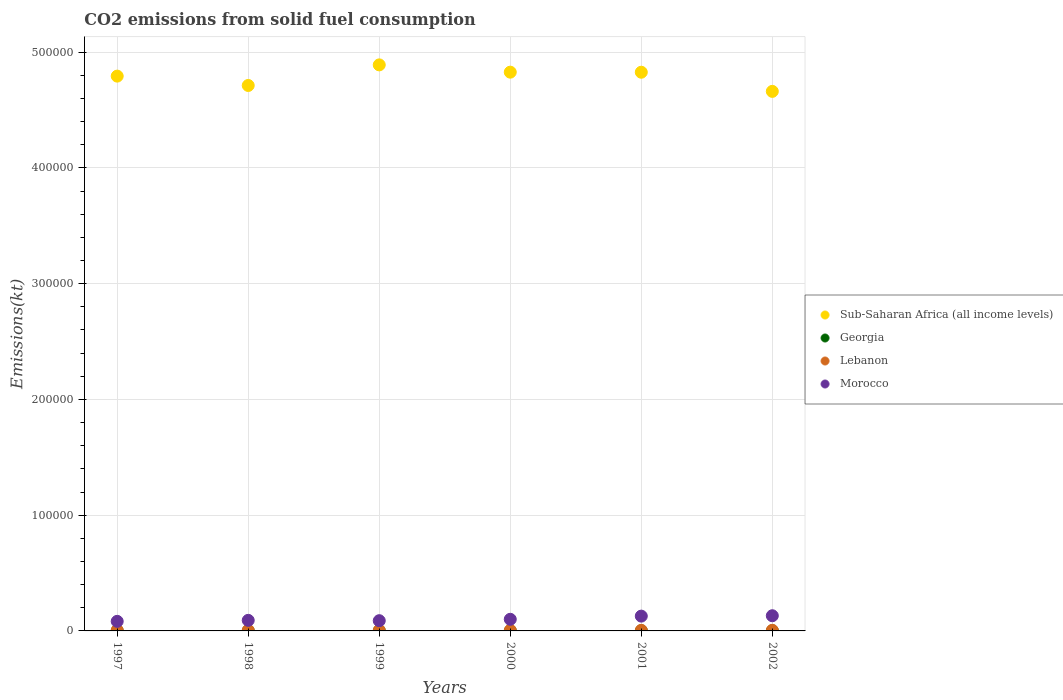How many different coloured dotlines are there?
Ensure brevity in your answer.  4. What is the amount of CO2 emitted in Lebanon in 2001?
Offer a very short reply. 531.72. Across all years, what is the maximum amount of CO2 emitted in Sub-Saharan Africa (all income levels)?
Provide a succinct answer. 4.89e+05. Across all years, what is the minimum amount of CO2 emitted in Lebanon?
Provide a succinct answer. 531.72. In which year was the amount of CO2 emitted in Lebanon maximum?
Ensure brevity in your answer.  1997. In which year was the amount of CO2 emitted in Morocco minimum?
Offer a very short reply. 1997. What is the total amount of CO2 emitted in Sub-Saharan Africa (all income levels) in the graph?
Keep it short and to the point. 2.87e+06. What is the difference between the amount of CO2 emitted in Morocco in 1999 and that in 2001?
Offer a terse response. -3942.03. What is the difference between the amount of CO2 emitted in Sub-Saharan Africa (all income levels) in 1998 and the amount of CO2 emitted in Morocco in 2001?
Your response must be concise. 4.58e+05. What is the average amount of CO2 emitted in Sub-Saharan Africa (all income levels) per year?
Provide a short and direct response. 4.78e+05. In the year 2002, what is the difference between the amount of CO2 emitted in Georgia and amount of CO2 emitted in Sub-Saharan Africa (all income levels)?
Keep it short and to the point. -4.66e+05. What is the ratio of the amount of CO2 emitted in Lebanon in 1999 to that in 2000?
Your answer should be compact. 1. What is the difference between the highest and the second highest amount of CO2 emitted in Morocco?
Give a very brief answer. 333.7. What is the difference between the highest and the lowest amount of CO2 emitted in Sub-Saharan Africa (all income levels)?
Offer a very short reply. 2.29e+04. Is the sum of the amount of CO2 emitted in Morocco in 2001 and 2002 greater than the maximum amount of CO2 emitted in Lebanon across all years?
Give a very brief answer. Yes. Is it the case that in every year, the sum of the amount of CO2 emitted in Morocco and amount of CO2 emitted in Sub-Saharan Africa (all income levels)  is greater than the sum of amount of CO2 emitted in Georgia and amount of CO2 emitted in Lebanon?
Your answer should be compact. No. Is it the case that in every year, the sum of the amount of CO2 emitted in Georgia and amount of CO2 emitted in Sub-Saharan Africa (all income levels)  is greater than the amount of CO2 emitted in Morocco?
Keep it short and to the point. Yes. Does the amount of CO2 emitted in Lebanon monotonically increase over the years?
Keep it short and to the point. No. Is the amount of CO2 emitted in Sub-Saharan Africa (all income levels) strictly greater than the amount of CO2 emitted in Morocco over the years?
Provide a succinct answer. Yes. Is the amount of CO2 emitted in Georgia strictly less than the amount of CO2 emitted in Sub-Saharan Africa (all income levels) over the years?
Provide a succinct answer. Yes. How many years are there in the graph?
Your answer should be very brief. 6. What is the difference between two consecutive major ticks on the Y-axis?
Provide a short and direct response. 1.00e+05. Does the graph contain grids?
Offer a terse response. Yes. Where does the legend appear in the graph?
Your answer should be very brief. Center right. How many legend labels are there?
Your answer should be compact. 4. What is the title of the graph?
Your response must be concise. CO2 emissions from solid fuel consumption. Does "St. Kitts and Nevis" appear as one of the legend labels in the graph?
Your answer should be very brief. No. What is the label or title of the Y-axis?
Your response must be concise. Emissions(kt). What is the Emissions(kt) of Sub-Saharan Africa (all income levels) in 1997?
Provide a succinct answer. 4.79e+05. What is the Emissions(kt) of Georgia in 1997?
Ensure brevity in your answer.  29.34. What is the Emissions(kt) in Lebanon in 1997?
Your response must be concise. 608.72. What is the Emissions(kt) of Morocco in 1997?
Offer a terse response. 8272.75. What is the Emissions(kt) in Sub-Saharan Africa (all income levels) in 1998?
Your response must be concise. 4.71e+05. What is the Emissions(kt) of Georgia in 1998?
Make the answer very short. 77.01. What is the Emissions(kt) in Lebanon in 1998?
Offer a terse response. 531.72. What is the Emissions(kt) in Morocco in 1998?
Offer a terse response. 9134.5. What is the Emissions(kt) of Sub-Saharan Africa (all income levels) in 1999?
Make the answer very short. 4.89e+05. What is the Emissions(kt) in Georgia in 1999?
Ensure brevity in your answer.  62.34. What is the Emissions(kt) in Lebanon in 1999?
Offer a very short reply. 535.38. What is the Emissions(kt) of Morocco in 1999?
Provide a succinct answer. 8841.14. What is the Emissions(kt) in Sub-Saharan Africa (all income levels) in 2000?
Keep it short and to the point. 4.83e+05. What is the Emissions(kt) in Georgia in 2000?
Provide a succinct answer. 58.67. What is the Emissions(kt) of Lebanon in 2000?
Your response must be concise. 535.38. What is the Emissions(kt) of Morocco in 2000?
Offer a very short reply. 1.00e+04. What is the Emissions(kt) in Sub-Saharan Africa (all income levels) in 2001?
Make the answer very short. 4.83e+05. What is the Emissions(kt) in Georgia in 2001?
Keep it short and to the point. 55.01. What is the Emissions(kt) of Lebanon in 2001?
Provide a succinct answer. 531.72. What is the Emissions(kt) of Morocco in 2001?
Offer a terse response. 1.28e+04. What is the Emissions(kt) of Sub-Saharan Africa (all income levels) in 2002?
Your answer should be compact. 4.66e+05. What is the Emissions(kt) in Georgia in 2002?
Make the answer very short. 55.01. What is the Emissions(kt) of Lebanon in 2002?
Ensure brevity in your answer.  531.72. What is the Emissions(kt) in Morocco in 2002?
Offer a very short reply. 1.31e+04. Across all years, what is the maximum Emissions(kt) in Sub-Saharan Africa (all income levels)?
Ensure brevity in your answer.  4.89e+05. Across all years, what is the maximum Emissions(kt) in Georgia?
Keep it short and to the point. 77.01. Across all years, what is the maximum Emissions(kt) of Lebanon?
Your answer should be very brief. 608.72. Across all years, what is the maximum Emissions(kt) in Morocco?
Ensure brevity in your answer.  1.31e+04. Across all years, what is the minimum Emissions(kt) in Sub-Saharan Africa (all income levels)?
Your answer should be very brief. 4.66e+05. Across all years, what is the minimum Emissions(kt) in Georgia?
Keep it short and to the point. 29.34. Across all years, what is the minimum Emissions(kt) in Lebanon?
Provide a succinct answer. 531.72. Across all years, what is the minimum Emissions(kt) in Morocco?
Your answer should be compact. 8272.75. What is the total Emissions(kt) of Sub-Saharan Africa (all income levels) in the graph?
Provide a short and direct response. 2.87e+06. What is the total Emissions(kt) of Georgia in the graph?
Keep it short and to the point. 337.36. What is the total Emissions(kt) in Lebanon in the graph?
Your answer should be very brief. 3274.63. What is the total Emissions(kt) in Morocco in the graph?
Ensure brevity in your answer.  6.22e+04. What is the difference between the Emissions(kt) in Sub-Saharan Africa (all income levels) in 1997 and that in 1998?
Your answer should be very brief. 8083.93. What is the difference between the Emissions(kt) in Georgia in 1997 and that in 1998?
Give a very brief answer. -47.67. What is the difference between the Emissions(kt) of Lebanon in 1997 and that in 1998?
Keep it short and to the point. 77.01. What is the difference between the Emissions(kt) in Morocco in 1997 and that in 1998?
Keep it short and to the point. -861.75. What is the difference between the Emissions(kt) of Sub-Saharan Africa (all income levels) in 1997 and that in 1999?
Provide a short and direct response. -9710.18. What is the difference between the Emissions(kt) of Georgia in 1997 and that in 1999?
Offer a terse response. -33. What is the difference between the Emissions(kt) of Lebanon in 1997 and that in 1999?
Offer a terse response. 73.34. What is the difference between the Emissions(kt) of Morocco in 1997 and that in 1999?
Give a very brief answer. -568.38. What is the difference between the Emissions(kt) in Sub-Saharan Africa (all income levels) in 1997 and that in 2000?
Provide a succinct answer. -3411.74. What is the difference between the Emissions(kt) in Georgia in 1997 and that in 2000?
Give a very brief answer. -29.34. What is the difference between the Emissions(kt) in Lebanon in 1997 and that in 2000?
Provide a short and direct response. 73.34. What is the difference between the Emissions(kt) in Morocco in 1997 and that in 2000?
Your response must be concise. -1763.83. What is the difference between the Emissions(kt) of Sub-Saharan Africa (all income levels) in 1997 and that in 2001?
Offer a very short reply. -3355.14. What is the difference between the Emissions(kt) in Georgia in 1997 and that in 2001?
Make the answer very short. -25.67. What is the difference between the Emissions(kt) of Lebanon in 1997 and that in 2001?
Offer a terse response. 77.01. What is the difference between the Emissions(kt) in Morocco in 1997 and that in 2001?
Provide a succinct answer. -4510.41. What is the difference between the Emissions(kt) of Sub-Saharan Africa (all income levels) in 1997 and that in 2002?
Your response must be concise. 1.32e+04. What is the difference between the Emissions(kt) in Georgia in 1997 and that in 2002?
Your answer should be compact. -25.67. What is the difference between the Emissions(kt) of Lebanon in 1997 and that in 2002?
Provide a short and direct response. 77.01. What is the difference between the Emissions(kt) in Morocco in 1997 and that in 2002?
Your answer should be compact. -4844.11. What is the difference between the Emissions(kt) of Sub-Saharan Africa (all income levels) in 1998 and that in 1999?
Your response must be concise. -1.78e+04. What is the difference between the Emissions(kt) in Georgia in 1998 and that in 1999?
Make the answer very short. 14.67. What is the difference between the Emissions(kt) in Lebanon in 1998 and that in 1999?
Your answer should be very brief. -3.67. What is the difference between the Emissions(kt) in Morocco in 1998 and that in 1999?
Make the answer very short. 293.36. What is the difference between the Emissions(kt) in Sub-Saharan Africa (all income levels) in 1998 and that in 2000?
Ensure brevity in your answer.  -1.15e+04. What is the difference between the Emissions(kt) of Georgia in 1998 and that in 2000?
Offer a terse response. 18.34. What is the difference between the Emissions(kt) in Lebanon in 1998 and that in 2000?
Keep it short and to the point. -3.67. What is the difference between the Emissions(kt) in Morocco in 1998 and that in 2000?
Keep it short and to the point. -902.08. What is the difference between the Emissions(kt) in Sub-Saharan Africa (all income levels) in 1998 and that in 2001?
Make the answer very short. -1.14e+04. What is the difference between the Emissions(kt) of Georgia in 1998 and that in 2001?
Provide a short and direct response. 22. What is the difference between the Emissions(kt) in Lebanon in 1998 and that in 2001?
Your answer should be very brief. 0. What is the difference between the Emissions(kt) in Morocco in 1998 and that in 2001?
Your answer should be compact. -3648.66. What is the difference between the Emissions(kt) in Sub-Saharan Africa (all income levels) in 1998 and that in 2002?
Your answer should be very brief. 5099.47. What is the difference between the Emissions(kt) in Georgia in 1998 and that in 2002?
Provide a short and direct response. 22. What is the difference between the Emissions(kt) in Morocco in 1998 and that in 2002?
Make the answer very short. -3982.36. What is the difference between the Emissions(kt) of Sub-Saharan Africa (all income levels) in 1999 and that in 2000?
Make the answer very short. 6298.44. What is the difference between the Emissions(kt) in Georgia in 1999 and that in 2000?
Offer a terse response. 3.67. What is the difference between the Emissions(kt) in Lebanon in 1999 and that in 2000?
Keep it short and to the point. 0. What is the difference between the Emissions(kt) of Morocco in 1999 and that in 2000?
Offer a very short reply. -1195.44. What is the difference between the Emissions(kt) of Sub-Saharan Africa (all income levels) in 1999 and that in 2001?
Provide a short and direct response. 6355.04. What is the difference between the Emissions(kt) in Georgia in 1999 and that in 2001?
Your response must be concise. 7.33. What is the difference between the Emissions(kt) in Lebanon in 1999 and that in 2001?
Your response must be concise. 3.67. What is the difference between the Emissions(kt) of Morocco in 1999 and that in 2001?
Ensure brevity in your answer.  -3942.03. What is the difference between the Emissions(kt) in Sub-Saharan Africa (all income levels) in 1999 and that in 2002?
Your answer should be compact. 2.29e+04. What is the difference between the Emissions(kt) in Georgia in 1999 and that in 2002?
Keep it short and to the point. 7.33. What is the difference between the Emissions(kt) of Lebanon in 1999 and that in 2002?
Offer a terse response. 3.67. What is the difference between the Emissions(kt) in Morocco in 1999 and that in 2002?
Ensure brevity in your answer.  -4275.72. What is the difference between the Emissions(kt) in Sub-Saharan Africa (all income levels) in 2000 and that in 2001?
Make the answer very short. 56.6. What is the difference between the Emissions(kt) of Georgia in 2000 and that in 2001?
Ensure brevity in your answer.  3.67. What is the difference between the Emissions(kt) in Lebanon in 2000 and that in 2001?
Provide a short and direct response. 3.67. What is the difference between the Emissions(kt) in Morocco in 2000 and that in 2001?
Your answer should be very brief. -2746.58. What is the difference between the Emissions(kt) in Sub-Saharan Africa (all income levels) in 2000 and that in 2002?
Your response must be concise. 1.66e+04. What is the difference between the Emissions(kt) of Georgia in 2000 and that in 2002?
Give a very brief answer. 3.67. What is the difference between the Emissions(kt) in Lebanon in 2000 and that in 2002?
Ensure brevity in your answer.  3.67. What is the difference between the Emissions(kt) of Morocco in 2000 and that in 2002?
Give a very brief answer. -3080.28. What is the difference between the Emissions(kt) in Sub-Saharan Africa (all income levels) in 2001 and that in 2002?
Ensure brevity in your answer.  1.65e+04. What is the difference between the Emissions(kt) of Georgia in 2001 and that in 2002?
Your response must be concise. 0. What is the difference between the Emissions(kt) of Morocco in 2001 and that in 2002?
Keep it short and to the point. -333.7. What is the difference between the Emissions(kt) of Sub-Saharan Africa (all income levels) in 1997 and the Emissions(kt) of Georgia in 1998?
Your answer should be very brief. 4.79e+05. What is the difference between the Emissions(kt) in Sub-Saharan Africa (all income levels) in 1997 and the Emissions(kt) in Lebanon in 1998?
Make the answer very short. 4.79e+05. What is the difference between the Emissions(kt) in Sub-Saharan Africa (all income levels) in 1997 and the Emissions(kt) in Morocco in 1998?
Give a very brief answer. 4.70e+05. What is the difference between the Emissions(kt) of Georgia in 1997 and the Emissions(kt) of Lebanon in 1998?
Give a very brief answer. -502.38. What is the difference between the Emissions(kt) in Georgia in 1997 and the Emissions(kt) in Morocco in 1998?
Keep it short and to the point. -9105.16. What is the difference between the Emissions(kt) in Lebanon in 1997 and the Emissions(kt) in Morocco in 1998?
Provide a succinct answer. -8525.77. What is the difference between the Emissions(kt) in Sub-Saharan Africa (all income levels) in 1997 and the Emissions(kt) in Georgia in 1999?
Ensure brevity in your answer.  4.79e+05. What is the difference between the Emissions(kt) in Sub-Saharan Africa (all income levels) in 1997 and the Emissions(kt) in Lebanon in 1999?
Offer a very short reply. 4.79e+05. What is the difference between the Emissions(kt) in Sub-Saharan Africa (all income levels) in 1997 and the Emissions(kt) in Morocco in 1999?
Ensure brevity in your answer.  4.70e+05. What is the difference between the Emissions(kt) of Georgia in 1997 and the Emissions(kt) of Lebanon in 1999?
Provide a short and direct response. -506.05. What is the difference between the Emissions(kt) in Georgia in 1997 and the Emissions(kt) in Morocco in 1999?
Your answer should be compact. -8811.8. What is the difference between the Emissions(kt) in Lebanon in 1997 and the Emissions(kt) in Morocco in 1999?
Offer a terse response. -8232.42. What is the difference between the Emissions(kt) in Sub-Saharan Africa (all income levels) in 1997 and the Emissions(kt) in Georgia in 2000?
Your answer should be compact. 4.79e+05. What is the difference between the Emissions(kt) in Sub-Saharan Africa (all income levels) in 1997 and the Emissions(kt) in Lebanon in 2000?
Keep it short and to the point. 4.79e+05. What is the difference between the Emissions(kt) of Sub-Saharan Africa (all income levels) in 1997 and the Emissions(kt) of Morocco in 2000?
Ensure brevity in your answer.  4.69e+05. What is the difference between the Emissions(kt) in Georgia in 1997 and the Emissions(kt) in Lebanon in 2000?
Your answer should be compact. -506.05. What is the difference between the Emissions(kt) of Georgia in 1997 and the Emissions(kt) of Morocco in 2000?
Offer a terse response. -1.00e+04. What is the difference between the Emissions(kt) of Lebanon in 1997 and the Emissions(kt) of Morocco in 2000?
Offer a terse response. -9427.86. What is the difference between the Emissions(kt) of Sub-Saharan Africa (all income levels) in 1997 and the Emissions(kt) of Georgia in 2001?
Your answer should be very brief. 4.79e+05. What is the difference between the Emissions(kt) of Sub-Saharan Africa (all income levels) in 1997 and the Emissions(kt) of Lebanon in 2001?
Your response must be concise. 4.79e+05. What is the difference between the Emissions(kt) of Sub-Saharan Africa (all income levels) in 1997 and the Emissions(kt) of Morocco in 2001?
Keep it short and to the point. 4.66e+05. What is the difference between the Emissions(kt) in Georgia in 1997 and the Emissions(kt) in Lebanon in 2001?
Make the answer very short. -502.38. What is the difference between the Emissions(kt) of Georgia in 1997 and the Emissions(kt) of Morocco in 2001?
Provide a succinct answer. -1.28e+04. What is the difference between the Emissions(kt) in Lebanon in 1997 and the Emissions(kt) in Morocco in 2001?
Make the answer very short. -1.22e+04. What is the difference between the Emissions(kt) in Sub-Saharan Africa (all income levels) in 1997 and the Emissions(kt) in Georgia in 2002?
Make the answer very short. 4.79e+05. What is the difference between the Emissions(kt) of Sub-Saharan Africa (all income levels) in 1997 and the Emissions(kt) of Lebanon in 2002?
Offer a terse response. 4.79e+05. What is the difference between the Emissions(kt) of Sub-Saharan Africa (all income levels) in 1997 and the Emissions(kt) of Morocco in 2002?
Provide a short and direct response. 4.66e+05. What is the difference between the Emissions(kt) in Georgia in 1997 and the Emissions(kt) in Lebanon in 2002?
Give a very brief answer. -502.38. What is the difference between the Emissions(kt) in Georgia in 1997 and the Emissions(kt) in Morocco in 2002?
Keep it short and to the point. -1.31e+04. What is the difference between the Emissions(kt) in Lebanon in 1997 and the Emissions(kt) in Morocco in 2002?
Provide a short and direct response. -1.25e+04. What is the difference between the Emissions(kt) in Sub-Saharan Africa (all income levels) in 1998 and the Emissions(kt) in Georgia in 1999?
Give a very brief answer. 4.71e+05. What is the difference between the Emissions(kt) in Sub-Saharan Africa (all income levels) in 1998 and the Emissions(kt) in Lebanon in 1999?
Make the answer very short. 4.71e+05. What is the difference between the Emissions(kt) of Sub-Saharan Africa (all income levels) in 1998 and the Emissions(kt) of Morocco in 1999?
Give a very brief answer. 4.62e+05. What is the difference between the Emissions(kt) of Georgia in 1998 and the Emissions(kt) of Lebanon in 1999?
Make the answer very short. -458.38. What is the difference between the Emissions(kt) of Georgia in 1998 and the Emissions(kt) of Morocco in 1999?
Make the answer very short. -8764.13. What is the difference between the Emissions(kt) of Lebanon in 1998 and the Emissions(kt) of Morocco in 1999?
Make the answer very short. -8309.42. What is the difference between the Emissions(kt) of Sub-Saharan Africa (all income levels) in 1998 and the Emissions(kt) of Georgia in 2000?
Your response must be concise. 4.71e+05. What is the difference between the Emissions(kt) of Sub-Saharan Africa (all income levels) in 1998 and the Emissions(kt) of Lebanon in 2000?
Give a very brief answer. 4.71e+05. What is the difference between the Emissions(kt) in Sub-Saharan Africa (all income levels) in 1998 and the Emissions(kt) in Morocco in 2000?
Give a very brief answer. 4.61e+05. What is the difference between the Emissions(kt) of Georgia in 1998 and the Emissions(kt) of Lebanon in 2000?
Give a very brief answer. -458.38. What is the difference between the Emissions(kt) in Georgia in 1998 and the Emissions(kt) in Morocco in 2000?
Give a very brief answer. -9959.57. What is the difference between the Emissions(kt) in Lebanon in 1998 and the Emissions(kt) in Morocco in 2000?
Your answer should be compact. -9504.86. What is the difference between the Emissions(kt) of Sub-Saharan Africa (all income levels) in 1998 and the Emissions(kt) of Georgia in 2001?
Make the answer very short. 4.71e+05. What is the difference between the Emissions(kt) in Sub-Saharan Africa (all income levels) in 1998 and the Emissions(kt) in Lebanon in 2001?
Your answer should be compact. 4.71e+05. What is the difference between the Emissions(kt) in Sub-Saharan Africa (all income levels) in 1998 and the Emissions(kt) in Morocco in 2001?
Your response must be concise. 4.58e+05. What is the difference between the Emissions(kt) in Georgia in 1998 and the Emissions(kt) in Lebanon in 2001?
Provide a short and direct response. -454.71. What is the difference between the Emissions(kt) in Georgia in 1998 and the Emissions(kt) in Morocco in 2001?
Offer a very short reply. -1.27e+04. What is the difference between the Emissions(kt) in Lebanon in 1998 and the Emissions(kt) in Morocco in 2001?
Give a very brief answer. -1.23e+04. What is the difference between the Emissions(kt) of Sub-Saharan Africa (all income levels) in 1998 and the Emissions(kt) of Georgia in 2002?
Provide a short and direct response. 4.71e+05. What is the difference between the Emissions(kt) in Sub-Saharan Africa (all income levels) in 1998 and the Emissions(kt) in Lebanon in 2002?
Ensure brevity in your answer.  4.71e+05. What is the difference between the Emissions(kt) in Sub-Saharan Africa (all income levels) in 1998 and the Emissions(kt) in Morocco in 2002?
Your answer should be very brief. 4.58e+05. What is the difference between the Emissions(kt) of Georgia in 1998 and the Emissions(kt) of Lebanon in 2002?
Give a very brief answer. -454.71. What is the difference between the Emissions(kt) of Georgia in 1998 and the Emissions(kt) of Morocco in 2002?
Provide a short and direct response. -1.30e+04. What is the difference between the Emissions(kt) of Lebanon in 1998 and the Emissions(kt) of Morocco in 2002?
Your answer should be very brief. -1.26e+04. What is the difference between the Emissions(kt) of Sub-Saharan Africa (all income levels) in 1999 and the Emissions(kt) of Georgia in 2000?
Provide a succinct answer. 4.89e+05. What is the difference between the Emissions(kt) in Sub-Saharan Africa (all income levels) in 1999 and the Emissions(kt) in Lebanon in 2000?
Make the answer very short. 4.88e+05. What is the difference between the Emissions(kt) in Sub-Saharan Africa (all income levels) in 1999 and the Emissions(kt) in Morocco in 2000?
Ensure brevity in your answer.  4.79e+05. What is the difference between the Emissions(kt) in Georgia in 1999 and the Emissions(kt) in Lebanon in 2000?
Offer a very short reply. -473.04. What is the difference between the Emissions(kt) in Georgia in 1999 and the Emissions(kt) in Morocco in 2000?
Keep it short and to the point. -9974.24. What is the difference between the Emissions(kt) in Lebanon in 1999 and the Emissions(kt) in Morocco in 2000?
Make the answer very short. -9501.2. What is the difference between the Emissions(kt) of Sub-Saharan Africa (all income levels) in 1999 and the Emissions(kt) of Georgia in 2001?
Provide a short and direct response. 4.89e+05. What is the difference between the Emissions(kt) in Sub-Saharan Africa (all income levels) in 1999 and the Emissions(kt) in Lebanon in 2001?
Your answer should be compact. 4.88e+05. What is the difference between the Emissions(kt) in Sub-Saharan Africa (all income levels) in 1999 and the Emissions(kt) in Morocco in 2001?
Offer a terse response. 4.76e+05. What is the difference between the Emissions(kt) of Georgia in 1999 and the Emissions(kt) of Lebanon in 2001?
Your response must be concise. -469.38. What is the difference between the Emissions(kt) in Georgia in 1999 and the Emissions(kt) in Morocco in 2001?
Make the answer very short. -1.27e+04. What is the difference between the Emissions(kt) of Lebanon in 1999 and the Emissions(kt) of Morocco in 2001?
Your answer should be very brief. -1.22e+04. What is the difference between the Emissions(kt) of Sub-Saharan Africa (all income levels) in 1999 and the Emissions(kt) of Georgia in 2002?
Your response must be concise. 4.89e+05. What is the difference between the Emissions(kt) of Sub-Saharan Africa (all income levels) in 1999 and the Emissions(kt) of Lebanon in 2002?
Provide a succinct answer. 4.88e+05. What is the difference between the Emissions(kt) in Sub-Saharan Africa (all income levels) in 1999 and the Emissions(kt) in Morocco in 2002?
Your response must be concise. 4.76e+05. What is the difference between the Emissions(kt) of Georgia in 1999 and the Emissions(kt) of Lebanon in 2002?
Provide a short and direct response. -469.38. What is the difference between the Emissions(kt) in Georgia in 1999 and the Emissions(kt) in Morocco in 2002?
Provide a succinct answer. -1.31e+04. What is the difference between the Emissions(kt) in Lebanon in 1999 and the Emissions(kt) in Morocco in 2002?
Make the answer very short. -1.26e+04. What is the difference between the Emissions(kt) in Sub-Saharan Africa (all income levels) in 2000 and the Emissions(kt) in Georgia in 2001?
Your response must be concise. 4.83e+05. What is the difference between the Emissions(kt) of Sub-Saharan Africa (all income levels) in 2000 and the Emissions(kt) of Lebanon in 2001?
Keep it short and to the point. 4.82e+05. What is the difference between the Emissions(kt) in Sub-Saharan Africa (all income levels) in 2000 and the Emissions(kt) in Morocco in 2001?
Offer a very short reply. 4.70e+05. What is the difference between the Emissions(kt) of Georgia in 2000 and the Emissions(kt) of Lebanon in 2001?
Your answer should be very brief. -473.04. What is the difference between the Emissions(kt) of Georgia in 2000 and the Emissions(kt) of Morocco in 2001?
Your response must be concise. -1.27e+04. What is the difference between the Emissions(kt) in Lebanon in 2000 and the Emissions(kt) in Morocco in 2001?
Keep it short and to the point. -1.22e+04. What is the difference between the Emissions(kt) of Sub-Saharan Africa (all income levels) in 2000 and the Emissions(kt) of Georgia in 2002?
Your answer should be very brief. 4.83e+05. What is the difference between the Emissions(kt) in Sub-Saharan Africa (all income levels) in 2000 and the Emissions(kt) in Lebanon in 2002?
Your answer should be compact. 4.82e+05. What is the difference between the Emissions(kt) in Sub-Saharan Africa (all income levels) in 2000 and the Emissions(kt) in Morocco in 2002?
Ensure brevity in your answer.  4.70e+05. What is the difference between the Emissions(kt) in Georgia in 2000 and the Emissions(kt) in Lebanon in 2002?
Your answer should be very brief. -473.04. What is the difference between the Emissions(kt) of Georgia in 2000 and the Emissions(kt) of Morocco in 2002?
Your response must be concise. -1.31e+04. What is the difference between the Emissions(kt) in Lebanon in 2000 and the Emissions(kt) in Morocco in 2002?
Your answer should be compact. -1.26e+04. What is the difference between the Emissions(kt) in Sub-Saharan Africa (all income levels) in 2001 and the Emissions(kt) in Georgia in 2002?
Offer a very short reply. 4.83e+05. What is the difference between the Emissions(kt) in Sub-Saharan Africa (all income levels) in 2001 and the Emissions(kt) in Lebanon in 2002?
Provide a succinct answer. 4.82e+05. What is the difference between the Emissions(kt) in Sub-Saharan Africa (all income levels) in 2001 and the Emissions(kt) in Morocco in 2002?
Your answer should be very brief. 4.69e+05. What is the difference between the Emissions(kt) of Georgia in 2001 and the Emissions(kt) of Lebanon in 2002?
Make the answer very short. -476.71. What is the difference between the Emissions(kt) of Georgia in 2001 and the Emissions(kt) of Morocco in 2002?
Your answer should be compact. -1.31e+04. What is the difference between the Emissions(kt) in Lebanon in 2001 and the Emissions(kt) in Morocco in 2002?
Ensure brevity in your answer.  -1.26e+04. What is the average Emissions(kt) of Sub-Saharan Africa (all income levels) per year?
Provide a succinct answer. 4.78e+05. What is the average Emissions(kt) of Georgia per year?
Offer a very short reply. 56.23. What is the average Emissions(kt) in Lebanon per year?
Your answer should be compact. 545.77. What is the average Emissions(kt) in Morocco per year?
Your response must be concise. 1.04e+04. In the year 1997, what is the difference between the Emissions(kt) in Sub-Saharan Africa (all income levels) and Emissions(kt) in Georgia?
Provide a succinct answer. 4.79e+05. In the year 1997, what is the difference between the Emissions(kt) in Sub-Saharan Africa (all income levels) and Emissions(kt) in Lebanon?
Offer a very short reply. 4.79e+05. In the year 1997, what is the difference between the Emissions(kt) in Sub-Saharan Africa (all income levels) and Emissions(kt) in Morocco?
Offer a terse response. 4.71e+05. In the year 1997, what is the difference between the Emissions(kt) in Georgia and Emissions(kt) in Lebanon?
Offer a very short reply. -579.39. In the year 1997, what is the difference between the Emissions(kt) of Georgia and Emissions(kt) of Morocco?
Your answer should be compact. -8243.42. In the year 1997, what is the difference between the Emissions(kt) of Lebanon and Emissions(kt) of Morocco?
Provide a succinct answer. -7664.03. In the year 1998, what is the difference between the Emissions(kt) in Sub-Saharan Africa (all income levels) and Emissions(kt) in Georgia?
Keep it short and to the point. 4.71e+05. In the year 1998, what is the difference between the Emissions(kt) of Sub-Saharan Africa (all income levels) and Emissions(kt) of Lebanon?
Give a very brief answer. 4.71e+05. In the year 1998, what is the difference between the Emissions(kt) of Sub-Saharan Africa (all income levels) and Emissions(kt) of Morocco?
Your answer should be compact. 4.62e+05. In the year 1998, what is the difference between the Emissions(kt) of Georgia and Emissions(kt) of Lebanon?
Keep it short and to the point. -454.71. In the year 1998, what is the difference between the Emissions(kt) of Georgia and Emissions(kt) of Morocco?
Ensure brevity in your answer.  -9057.49. In the year 1998, what is the difference between the Emissions(kt) of Lebanon and Emissions(kt) of Morocco?
Provide a short and direct response. -8602.78. In the year 1999, what is the difference between the Emissions(kt) in Sub-Saharan Africa (all income levels) and Emissions(kt) in Georgia?
Keep it short and to the point. 4.89e+05. In the year 1999, what is the difference between the Emissions(kt) of Sub-Saharan Africa (all income levels) and Emissions(kt) of Lebanon?
Give a very brief answer. 4.88e+05. In the year 1999, what is the difference between the Emissions(kt) of Sub-Saharan Africa (all income levels) and Emissions(kt) of Morocco?
Keep it short and to the point. 4.80e+05. In the year 1999, what is the difference between the Emissions(kt) of Georgia and Emissions(kt) of Lebanon?
Offer a very short reply. -473.04. In the year 1999, what is the difference between the Emissions(kt) of Georgia and Emissions(kt) of Morocco?
Keep it short and to the point. -8778.8. In the year 1999, what is the difference between the Emissions(kt) in Lebanon and Emissions(kt) in Morocco?
Ensure brevity in your answer.  -8305.75. In the year 2000, what is the difference between the Emissions(kt) in Sub-Saharan Africa (all income levels) and Emissions(kt) in Georgia?
Offer a very short reply. 4.83e+05. In the year 2000, what is the difference between the Emissions(kt) in Sub-Saharan Africa (all income levels) and Emissions(kt) in Lebanon?
Offer a terse response. 4.82e+05. In the year 2000, what is the difference between the Emissions(kt) of Sub-Saharan Africa (all income levels) and Emissions(kt) of Morocco?
Make the answer very short. 4.73e+05. In the year 2000, what is the difference between the Emissions(kt) of Georgia and Emissions(kt) of Lebanon?
Your response must be concise. -476.71. In the year 2000, what is the difference between the Emissions(kt) of Georgia and Emissions(kt) of Morocco?
Keep it short and to the point. -9977.91. In the year 2000, what is the difference between the Emissions(kt) in Lebanon and Emissions(kt) in Morocco?
Ensure brevity in your answer.  -9501.2. In the year 2001, what is the difference between the Emissions(kt) of Sub-Saharan Africa (all income levels) and Emissions(kt) of Georgia?
Provide a short and direct response. 4.83e+05. In the year 2001, what is the difference between the Emissions(kt) of Sub-Saharan Africa (all income levels) and Emissions(kt) of Lebanon?
Provide a succinct answer. 4.82e+05. In the year 2001, what is the difference between the Emissions(kt) in Sub-Saharan Africa (all income levels) and Emissions(kt) in Morocco?
Keep it short and to the point. 4.70e+05. In the year 2001, what is the difference between the Emissions(kt) of Georgia and Emissions(kt) of Lebanon?
Ensure brevity in your answer.  -476.71. In the year 2001, what is the difference between the Emissions(kt) in Georgia and Emissions(kt) in Morocco?
Offer a very short reply. -1.27e+04. In the year 2001, what is the difference between the Emissions(kt) of Lebanon and Emissions(kt) of Morocco?
Your response must be concise. -1.23e+04. In the year 2002, what is the difference between the Emissions(kt) in Sub-Saharan Africa (all income levels) and Emissions(kt) in Georgia?
Keep it short and to the point. 4.66e+05. In the year 2002, what is the difference between the Emissions(kt) in Sub-Saharan Africa (all income levels) and Emissions(kt) in Lebanon?
Provide a short and direct response. 4.66e+05. In the year 2002, what is the difference between the Emissions(kt) in Sub-Saharan Africa (all income levels) and Emissions(kt) in Morocco?
Your answer should be compact. 4.53e+05. In the year 2002, what is the difference between the Emissions(kt) of Georgia and Emissions(kt) of Lebanon?
Your response must be concise. -476.71. In the year 2002, what is the difference between the Emissions(kt) in Georgia and Emissions(kt) in Morocco?
Ensure brevity in your answer.  -1.31e+04. In the year 2002, what is the difference between the Emissions(kt) of Lebanon and Emissions(kt) of Morocco?
Offer a terse response. -1.26e+04. What is the ratio of the Emissions(kt) in Sub-Saharan Africa (all income levels) in 1997 to that in 1998?
Your response must be concise. 1.02. What is the ratio of the Emissions(kt) in Georgia in 1997 to that in 1998?
Offer a terse response. 0.38. What is the ratio of the Emissions(kt) of Lebanon in 1997 to that in 1998?
Keep it short and to the point. 1.14. What is the ratio of the Emissions(kt) of Morocco in 1997 to that in 1998?
Your response must be concise. 0.91. What is the ratio of the Emissions(kt) of Sub-Saharan Africa (all income levels) in 1997 to that in 1999?
Give a very brief answer. 0.98. What is the ratio of the Emissions(kt) of Georgia in 1997 to that in 1999?
Make the answer very short. 0.47. What is the ratio of the Emissions(kt) in Lebanon in 1997 to that in 1999?
Your answer should be very brief. 1.14. What is the ratio of the Emissions(kt) of Morocco in 1997 to that in 1999?
Ensure brevity in your answer.  0.94. What is the ratio of the Emissions(kt) of Sub-Saharan Africa (all income levels) in 1997 to that in 2000?
Ensure brevity in your answer.  0.99. What is the ratio of the Emissions(kt) of Georgia in 1997 to that in 2000?
Offer a very short reply. 0.5. What is the ratio of the Emissions(kt) of Lebanon in 1997 to that in 2000?
Offer a terse response. 1.14. What is the ratio of the Emissions(kt) in Morocco in 1997 to that in 2000?
Your response must be concise. 0.82. What is the ratio of the Emissions(kt) in Georgia in 1997 to that in 2001?
Your answer should be compact. 0.53. What is the ratio of the Emissions(kt) of Lebanon in 1997 to that in 2001?
Your response must be concise. 1.14. What is the ratio of the Emissions(kt) in Morocco in 1997 to that in 2001?
Ensure brevity in your answer.  0.65. What is the ratio of the Emissions(kt) in Sub-Saharan Africa (all income levels) in 1997 to that in 2002?
Make the answer very short. 1.03. What is the ratio of the Emissions(kt) in Georgia in 1997 to that in 2002?
Provide a succinct answer. 0.53. What is the ratio of the Emissions(kt) of Lebanon in 1997 to that in 2002?
Give a very brief answer. 1.14. What is the ratio of the Emissions(kt) of Morocco in 1997 to that in 2002?
Keep it short and to the point. 0.63. What is the ratio of the Emissions(kt) of Sub-Saharan Africa (all income levels) in 1998 to that in 1999?
Make the answer very short. 0.96. What is the ratio of the Emissions(kt) of Georgia in 1998 to that in 1999?
Offer a terse response. 1.24. What is the ratio of the Emissions(kt) in Morocco in 1998 to that in 1999?
Your answer should be compact. 1.03. What is the ratio of the Emissions(kt) of Sub-Saharan Africa (all income levels) in 1998 to that in 2000?
Your answer should be very brief. 0.98. What is the ratio of the Emissions(kt) of Georgia in 1998 to that in 2000?
Your response must be concise. 1.31. What is the ratio of the Emissions(kt) of Lebanon in 1998 to that in 2000?
Keep it short and to the point. 0.99. What is the ratio of the Emissions(kt) in Morocco in 1998 to that in 2000?
Offer a terse response. 0.91. What is the ratio of the Emissions(kt) in Sub-Saharan Africa (all income levels) in 1998 to that in 2001?
Provide a succinct answer. 0.98. What is the ratio of the Emissions(kt) of Morocco in 1998 to that in 2001?
Your response must be concise. 0.71. What is the ratio of the Emissions(kt) in Sub-Saharan Africa (all income levels) in 1998 to that in 2002?
Keep it short and to the point. 1.01. What is the ratio of the Emissions(kt) of Lebanon in 1998 to that in 2002?
Provide a succinct answer. 1. What is the ratio of the Emissions(kt) of Morocco in 1998 to that in 2002?
Your response must be concise. 0.7. What is the ratio of the Emissions(kt) of Sub-Saharan Africa (all income levels) in 1999 to that in 2000?
Make the answer very short. 1.01. What is the ratio of the Emissions(kt) of Georgia in 1999 to that in 2000?
Your response must be concise. 1.06. What is the ratio of the Emissions(kt) of Lebanon in 1999 to that in 2000?
Your answer should be very brief. 1. What is the ratio of the Emissions(kt) of Morocco in 1999 to that in 2000?
Your response must be concise. 0.88. What is the ratio of the Emissions(kt) of Sub-Saharan Africa (all income levels) in 1999 to that in 2001?
Offer a very short reply. 1.01. What is the ratio of the Emissions(kt) in Georgia in 1999 to that in 2001?
Give a very brief answer. 1.13. What is the ratio of the Emissions(kt) in Morocco in 1999 to that in 2001?
Give a very brief answer. 0.69. What is the ratio of the Emissions(kt) in Sub-Saharan Africa (all income levels) in 1999 to that in 2002?
Make the answer very short. 1.05. What is the ratio of the Emissions(kt) in Georgia in 1999 to that in 2002?
Your answer should be very brief. 1.13. What is the ratio of the Emissions(kt) in Morocco in 1999 to that in 2002?
Your response must be concise. 0.67. What is the ratio of the Emissions(kt) in Georgia in 2000 to that in 2001?
Offer a very short reply. 1.07. What is the ratio of the Emissions(kt) of Lebanon in 2000 to that in 2001?
Provide a short and direct response. 1.01. What is the ratio of the Emissions(kt) in Morocco in 2000 to that in 2001?
Offer a terse response. 0.79. What is the ratio of the Emissions(kt) in Sub-Saharan Africa (all income levels) in 2000 to that in 2002?
Offer a very short reply. 1.04. What is the ratio of the Emissions(kt) in Georgia in 2000 to that in 2002?
Give a very brief answer. 1.07. What is the ratio of the Emissions(kt) of Morocco in 2000 to that in 2002?
Make the answer very short. 0.77. What is the ratio of the Emissions(kt) of Sub-Saharan Africa (all income levels) in 2001 to that in 2002?
Your response must be concise. 1.04. What is the ratio of the Emissions(kt) of Lebanon in 2001 to that in 2002?
Offer a terse response. 1. What is the ratio of the Emissions(kt) in Morocco in 2001 to that in 2002?
Provide a short and direct response. 0.97. What is the difference between the highest and the second highest Emissions(kt) in Sub-Saharan Africa (all income levels)?
Your answer should be compact. 6298.44. What is the difference between the highest and the second highest Emissions(kt) in Georgia?
Offer a very short reply. 14.67. What is the difference between the highest and the second highest Emissions(kt) of Lebanon?
Make the answer very short. 73.34. What is the difference between the highest and the second highest Emissions(kt) in Morocco?
Ensure brevity in your answer.  333.7. What is the difference between the highest and the lowest Emissions(kt) of Sub-Saharan Africa (all income levels)?
Give a very brief answer. 2.29e+04. What is the difference between the highest and the lowest Emissions(kt) of Georgia?
Your answer should be compact. 47.67. What is the difference between the highest and the lowest Emissions(kt) in Lebanon?
Your answer should be very brief. 77.01. What is the difference between the highest and the lowest Emissions(kt) in Morocco?
Ensure brevity in your answer.  4844.11. 